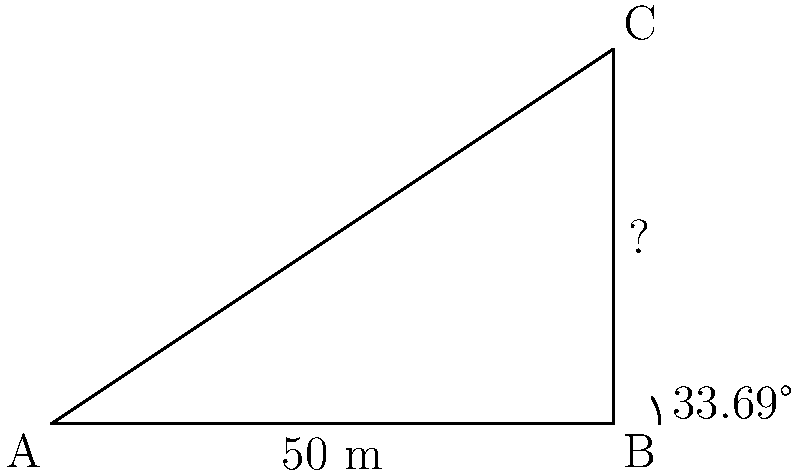As part of your research on religious architecture, you're studying a towering minaret at a historic mosque. Standing 50 meters away from the base of the minaret (point B), you use an inclinometer to measure the angle of elevation to the top of the minaret (point C) as 33.69°. What is the height of the minaret? Let's approach this step-by-step:

1) We can model this situation as a right-angled triangle, where:
   - The base (AB) is the distance from the observer to the minaret: 50 meters
   - The height (BC) is what we're trying to find
   - The angle of elevation at B is 33.69°

2) In this right-angled triangle, we know:
   - The adjacent side (AB) = 50 meters
   - The angle = 33.69°
   - We need to find the opposite side (BC)

3) This is a perfect scenario to use the tangent trigonometric function:

   $$\tan \theta = \frac{\text{opposite}}{\text{adjacent}}$$

4) Plugging in our known values:

   $$\tan 33.69° = \frac{\text{height}}{50}$$

5) To solve for the height, we multiply both sides by 50:

   $$50 \cdot \tan 33.69° = \text{height}$$

6) Now we can calculate:
   
   $$\text{height} = 50 \cdot \tan 33.69° \approx 33.33 \text{ meters}$$

7) Rounding to two decimal places, we get 33.33 meters.
Answer: 33.33 meters 